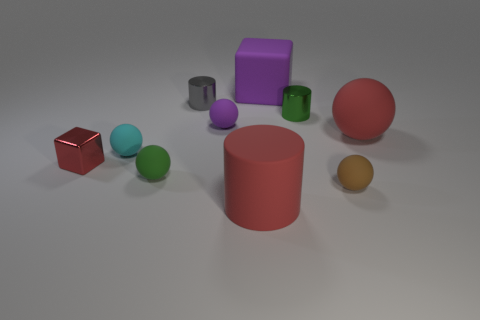Subtract all purple spheres. How many spheres are left? 4 Subtract all red balls. How many balls are left? 4 Subtract 1 cylinders. How many cylinders are left? 2 Subtract all purple balls. Subtract all green cylinders. How many balls are left? 4 Subtract all cylinders. How many objects are left? 7 Subtract 0 cyan cubes. How many objects are left? 10 Subtract all shiny blocks. Subtract all large red spheres. How many objects are left? 8 Add 6 brown things. How many brown things are left? 7 Add 6 brown things. How many brown things exist? 7 